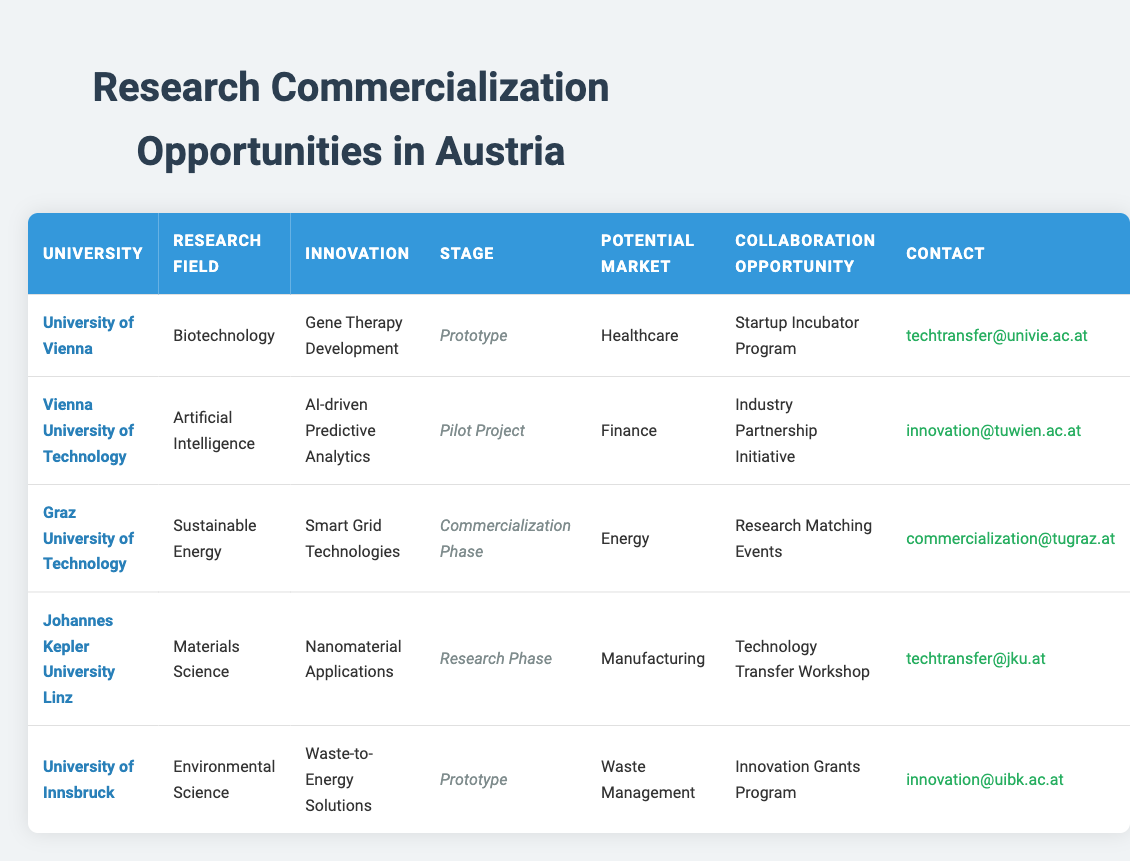What is the collaboration opportunity for the University of Vienna? The collaboration opportunity listed for the University of Vienna is the Startup Incubator Program, which is mentioned in the corresponding row of the table.
Answer: Startup Incubator Program Which university is focused on Artificial Intelligence? The table shows that the Vienna University of Technology is focused on Artificial Intelligence, as indicated in the "Research Field" column for that particular university.
Answer: Vienna University of Technology How many innovations are in the Prototype stage? There are two innovations in the Prototype stage: Gene Therapy Development from the University of Vienna and Waste-to-Energy Solutions from the University of Innsbruck. This can be verified by checking the "Stage" column for each university.
Answer: 2 Is there a collaboration opportunity related to sustainable energy research? Yes, Graz University of Technology offers collaboration opportunities through Research Matching Events, as indicated in the corresponding row of the table.
Answer: Yes What is the potential market for Nanomaterial Applications? The potential market for Nanomaterial Applications, as stated in the table, is Manufacturing. This information can be retrieved directly from the relevant row for Johannes Kepler University Linz.
Answer: Manufacturing Which university's innovation is at the Commercialization Phase? Graz University of Technology's innovation, Smart Grid Technologies, is at the Commercialization Phase. This is confirmed by looking under the "Stage" column for that university in the table.
Answer: Graz University of Technology How many universities are involved in the Healthcare market? Only one university, the University of Vienna, is involved in the Healthcare market, as indicated in the "Potential Market" column.
Answer: 1 What is the contact email for collaboration at the University of Innsbruck? The contact email for collaboration at the University of Innsbruck is innovation@uibk.ac.at, which can be found in the last row of the table.
Answer: innovation@uibk.ac.at Which research field is associated with the innovation AI-driven Predictive Analytics? The research field associated with the innovation AI-driven Predictive Analytics is Artificial Intelligence, as mentioned in the table under the relevant row for Vienna University of Technology.
Answer: Artificial Intelligence What is the stage of innovation for the research field of Environmental Science? The stage of innovation for the research field of Environmental Science is Prototype, as noted under the corresponding row for the University of Innsbruck in the table.
Answer: Prototype 